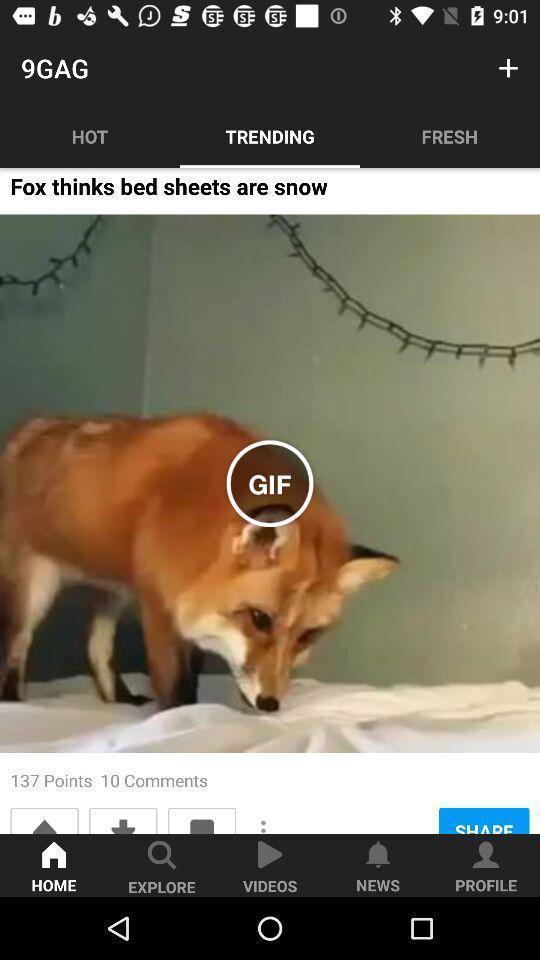Tell me about the visual elements in this screen capture. Screen shows trending options in a fun application. 